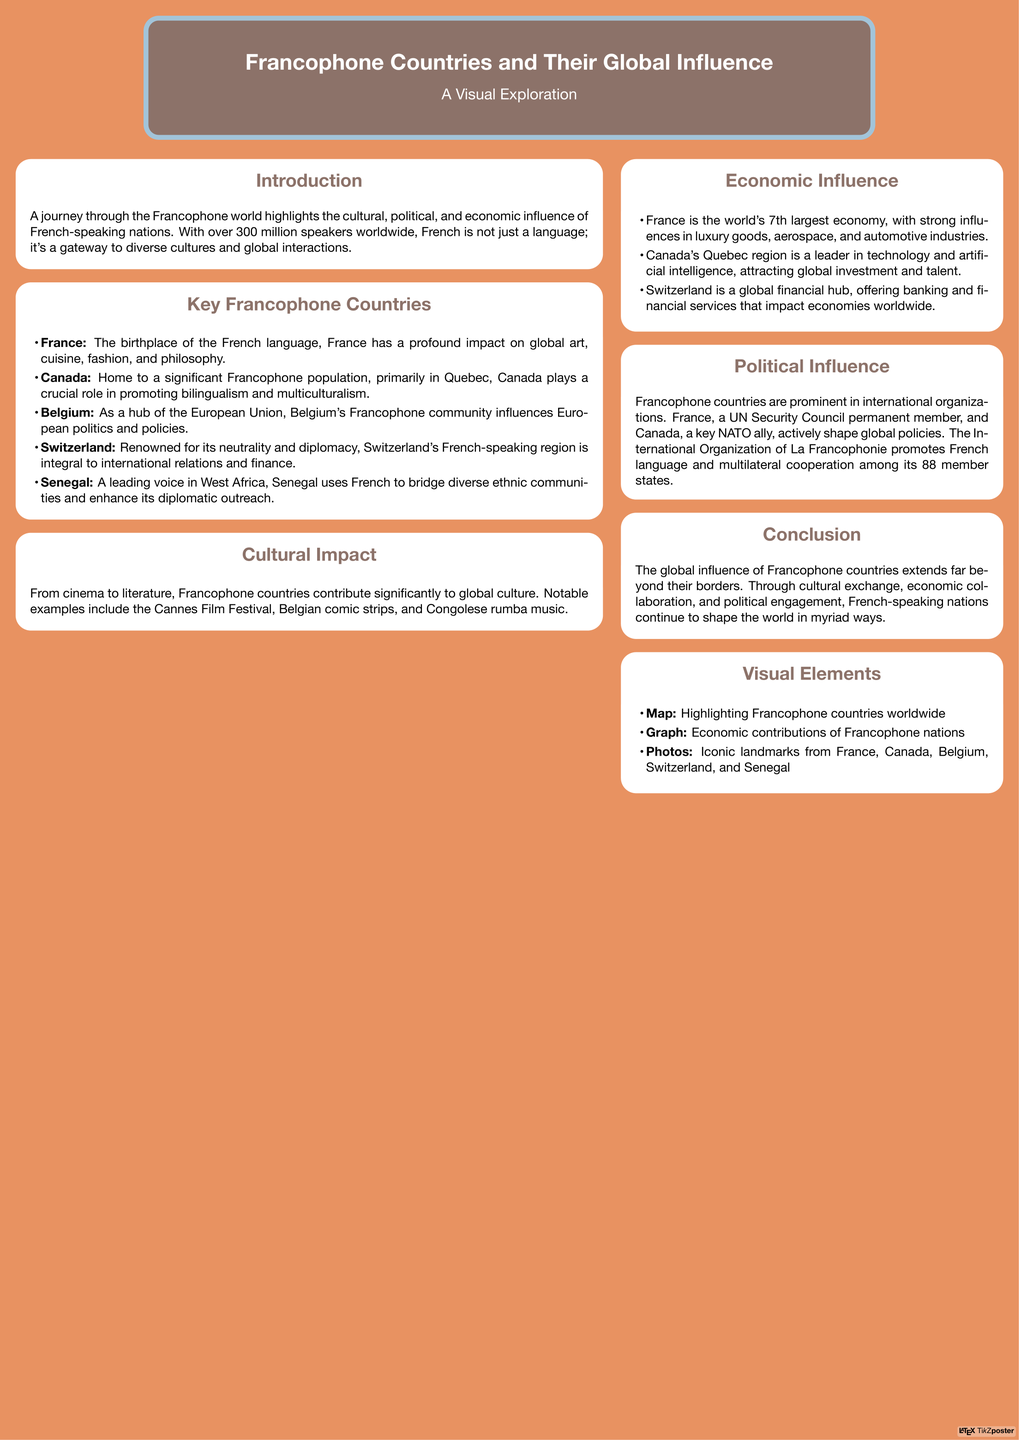What is the primary language spoken in Francophone countries? The primary language spoken in Francophone countries is French, as mentioned in the introduction of the document.
Answer: French Which country is the birthplace of the French language? The document specifies that France is the birthplace of the French language in the Key Francophone Countries section.
Answer: France How many speakers of French are there worldwide? The introduction states that there are over 300 million speakers of French worldwide.
Answer: 300 million What is Canada known for promoting? According to the Key Francophone Countries section, Canada plays a crucial role in promoting bilingualism and multiculturalism.
Answer: Bilingualism and multiculturalism Which organization promotes the French language? The document mentions that the International Organization of La Francophonie promotes the French language and multilateral cooperation.
Answer: International Organization of La Francophonie What is the significance of Switzerland in international relations? The document describes Switzerland as renowned for its neutrality and diplomacy, highlighting its importance in international relations.
Answer: Neutrality and diplomacy Which festival is associated with the cultural impact of Francophone countries? The document references the Cannes Film Festival as a significant cultural event linked to Francophone countries.
Answer: Cannes Film Festival Which region in Canada is a leader in technology? The document identifies Quebec as the region in Canada that is a leader in technology and artificial intelligence.
Answer: Quebec Which country is a permanent member of the UN Security Council? The document states that France is a permanent member of the UN Security Council.
Answer: France 